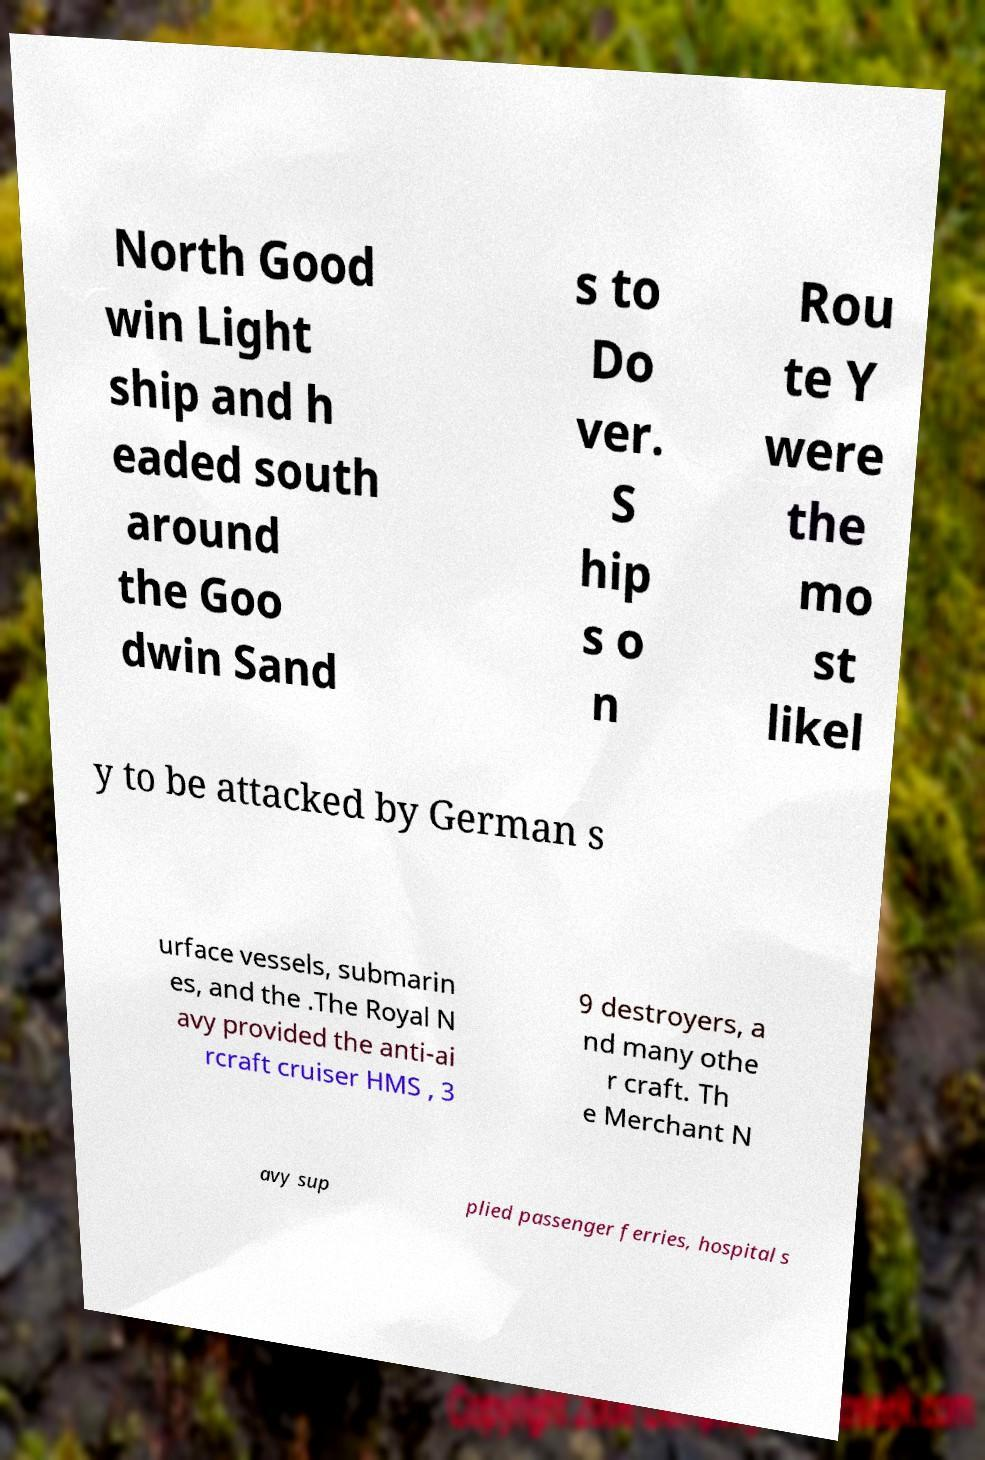Please read and relay the text visible in this image. What does it say? North Good win Light ship and h eaded south around the Goo dwin Sand s to Do ver. S hip s o n Rou te Y were the mo st likel y to be attacked by German s urface vessels, submarin es, and the .The Royal N avy provided the anti-ai rcraft cruiser HMS , 3 9 destroyers, a nd many othe r craft. Th e Merchant N avy sup plied passenger ferries, hospital s 